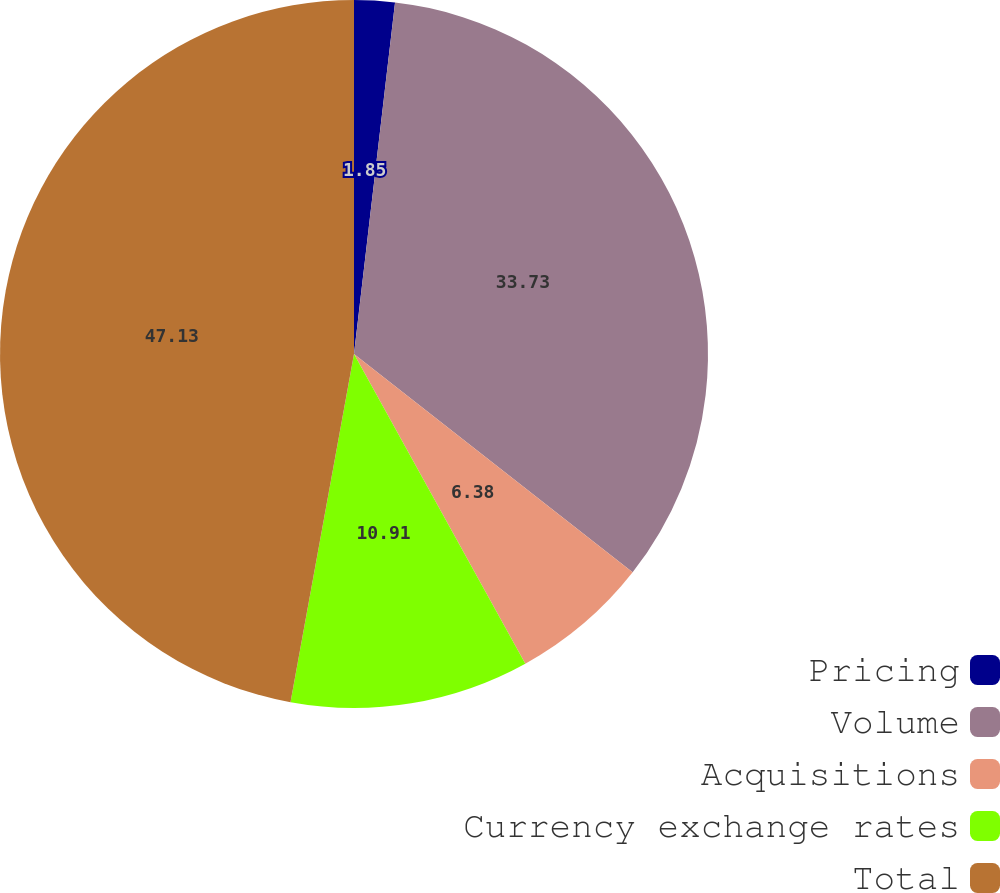Convert chart to OTSL. <chart><loc_0><loc_0><loc_500><loc_500><pie_chart><fcel>Pricing<fcel>Volume<fcel>Acquisitions<fcel>Currency exchange rates<fcel>Total<nl><fcel>1.85%<fcel>33.73%<fcel>6.38%<fcel>10.91%<fcel>47.13%<nl></chart> 